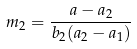<formula> <loc_0><loc_0><loc_500><loc_500>m _ { 2 } = \frac { a - a _ { 2 } } { b _ { 2 } ( a _ { 2 } - a _ { 1 } ) }</formula> 